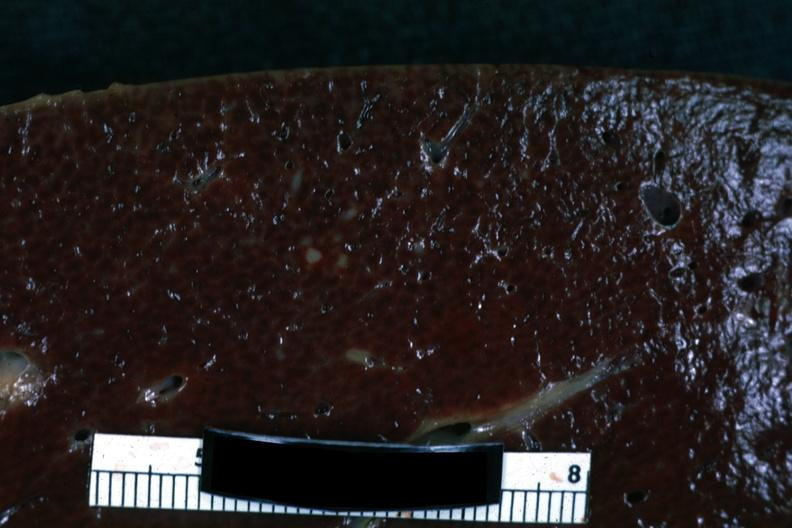where is this part in?
Answer the question using a single word or phrase. Spleen 